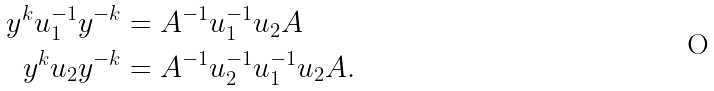Convert formula to latex. <formula><loc_0><loc_0><loc_500><loc_500>y ^ { k } u _ { 1 } ^ { - 1 } y ^ { - k } & = A ^ { - 1 } u _ { 1 } ^ { - 1 } u _ { 2 } A \\ y ^ { k } u _ { 2 } y ^ { - k } & = A ^ { - 1 } u _ { 2 } ^ { - 1 } u _ { 1 } ^ { - 1 } u _ { 2 } A .</formula> 